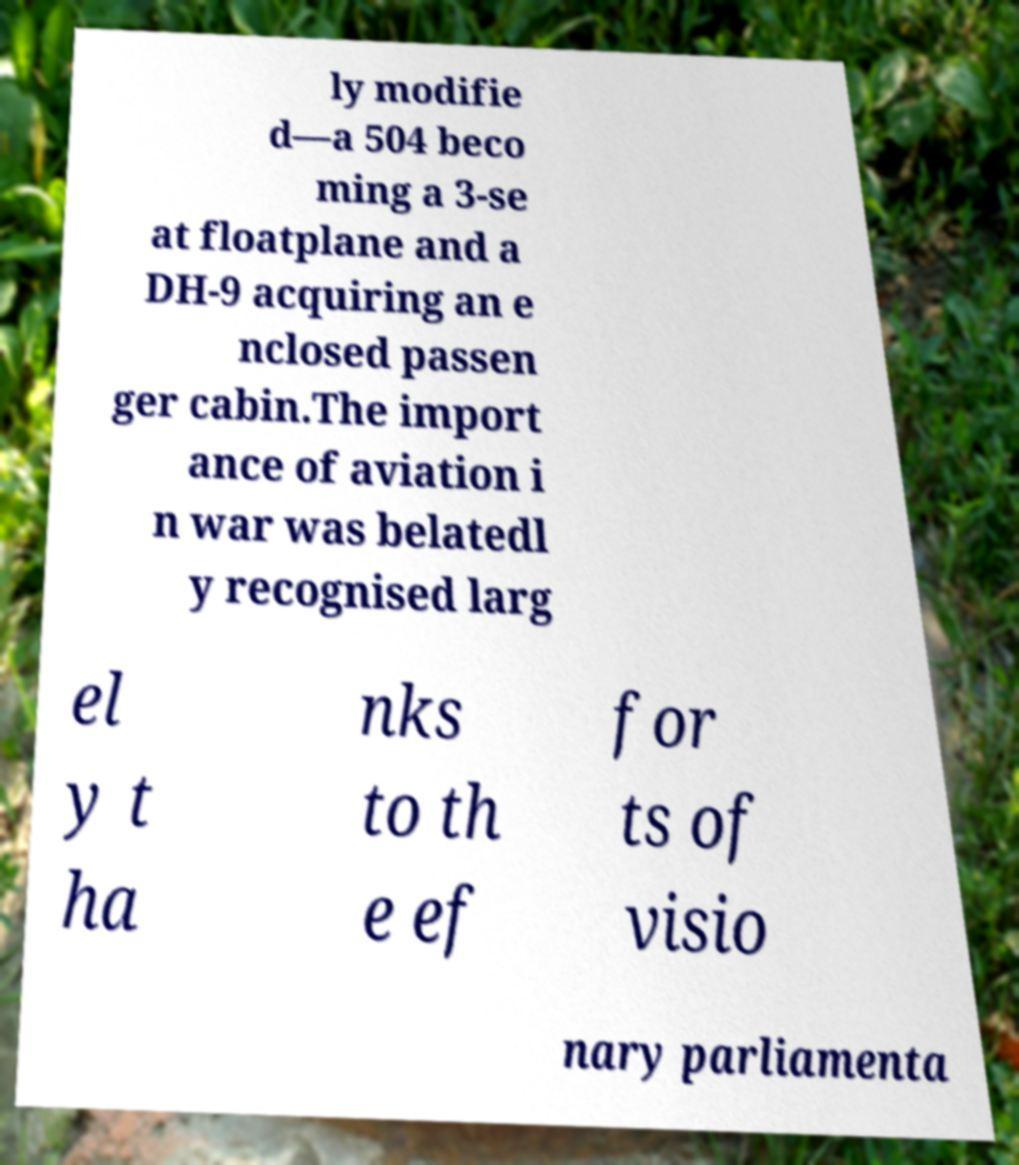What messages or text are displayed in this image? I need them in a readable, typed format. ly modifie d—a 504 beco ming a 3-se at floatplane and a DH-9 acquiring an e nclosed passen ger cabin.The import ance of aviation i n war was belatedl y recognised larg el y t ha nks to th e ef for ts of visio nary parliamenta 